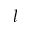Convert formula to latex. <formula><loc_0><loc_0><loc_500><loc_500>l</formula> 